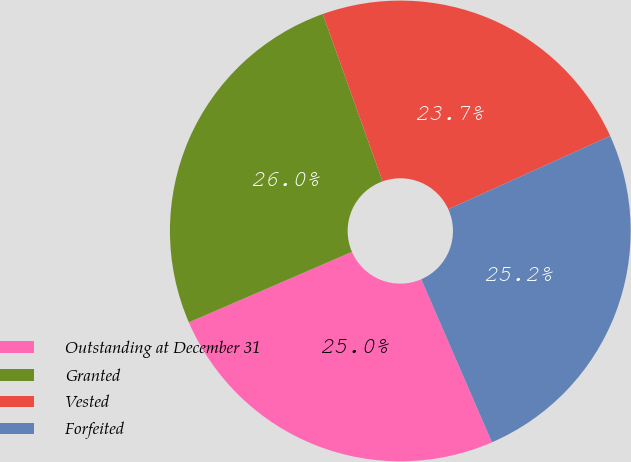<chart> <loc_0><loc_0><loc_500><loc_500><pie_chart><fcel>Outstanding at December 31<fcel>Granted<fcel>Vested<fcel>Forfeited<nl><fcel>25.02%<fcel>26.03%<fcel>23.7%<fcel>25.25%<nl></chart> 